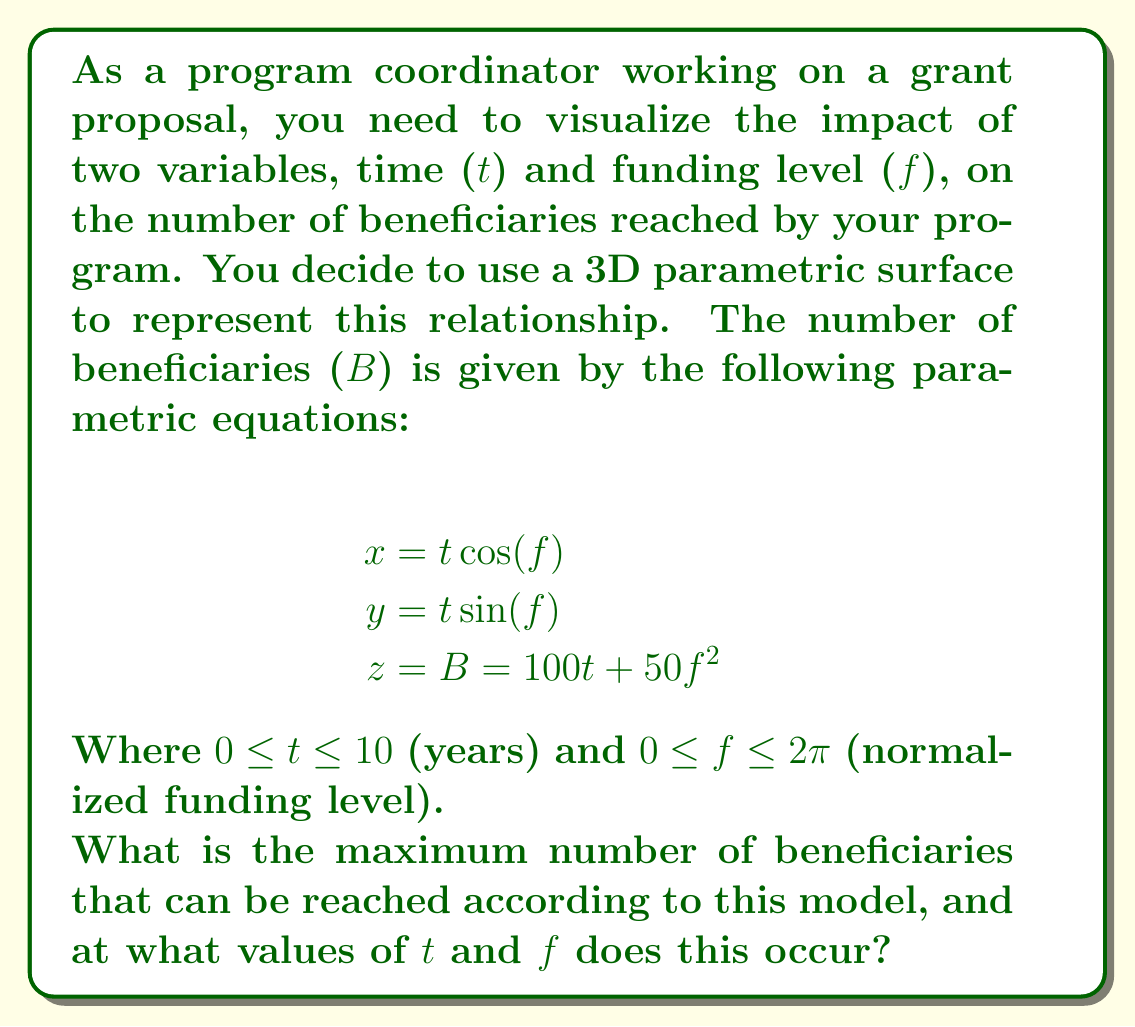Could you help me with this problem? To find the maximum number of beneficiaries, we need to maximize the function $B = 100t + 50f^2$. Let's approach this step-by-step:

1) First, note that $t$ and $f$ are independent variables in the equation for $B$. This means we can maximize each term separately.

2) For the term $100t$:
   - The maximum value will occur at the upper bound of $t$, which is 10.
   - Maximum contribution from this term: $100 \cdot 10 = 1000$

3) For the term $50f^2$:
   - This is a quadratic function of $f$, which reaches its maximum at the upper bound of $f$, which is $2\pi$.
   - Maximum contribution from this term: $50 \cdot (2\pi)^2 \approx 1973.92$

4) The maximum value of $B$ will occur when both $t$ and $f$ are at their maximum values:
   $B_{max} = 100 \cdot 10 + 50 \cdot (2\pi)^2 \approx 2973.92$

5) This maximum occurs at:
   $t = 10$ (years)
   $f = 2\pi$ (normalized funding level)

6) We can verify the $x$ and $y$ coordinates at this point:
   $x = 10 \cdot \cos(2\pi) = 10$
   $y = 10 \cdot \sin(2\pi) = 0$

Therefore, the point $(x, y, z)$ where the maximum occurs is approximately $(10, 0, 2973.92)$.
Answer: The maximum number of beneficiaries is approximately 2,974, occurring at $t = 10$ years and $f = 2\pi$ (normalized funding level). 